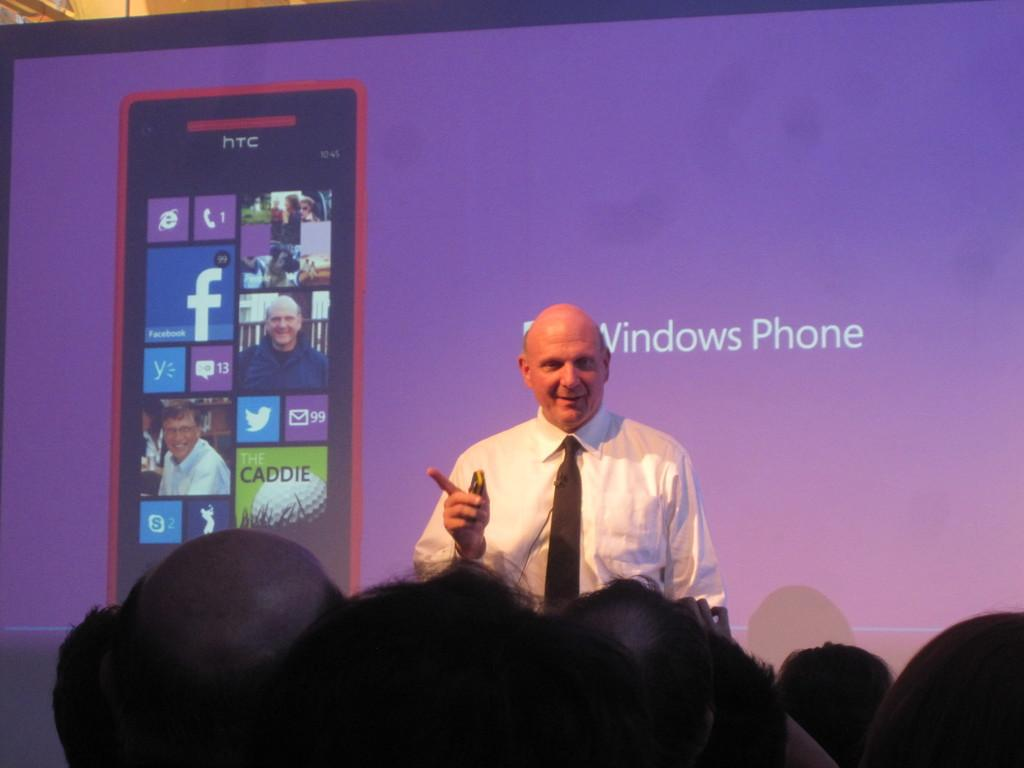<image>
Share a concise interpretation of the image provided. A bald man is speaking in front of a screen that says Windows Phone. 